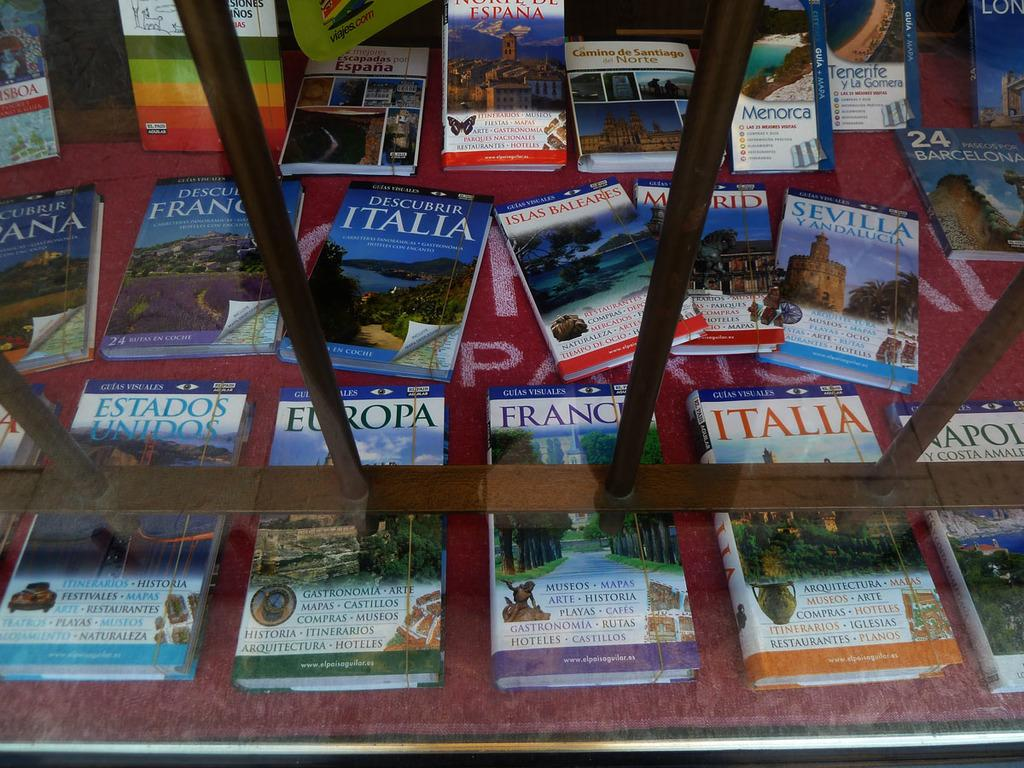<image>
Render a clear and concise summary of the photo. Books for various destinations including one titled Europa are laid out. 